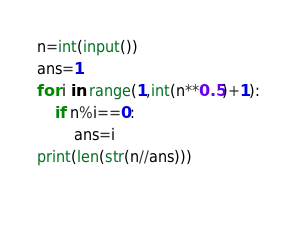Convert code to text. <code><loc_0><loc_0><loc_500><loc_500><_Python_>n=int(input())
ans=1
for i in range(1,int(n**0.5)+1):
    if n%i==0:
        ans=i
print(len(str(n//ans)))
    </code> 